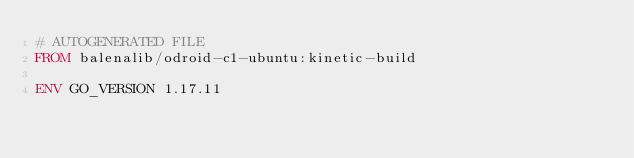Convert code to text. <code><loc_0><loc_0><loc_500><loc_500><_Dockerfile_># AUTOGENERATED FILE
FROM balenalib/odroid-c1-ubuntu:kinetic-build

ENV GO_VERSION 1.17.11
</code> 